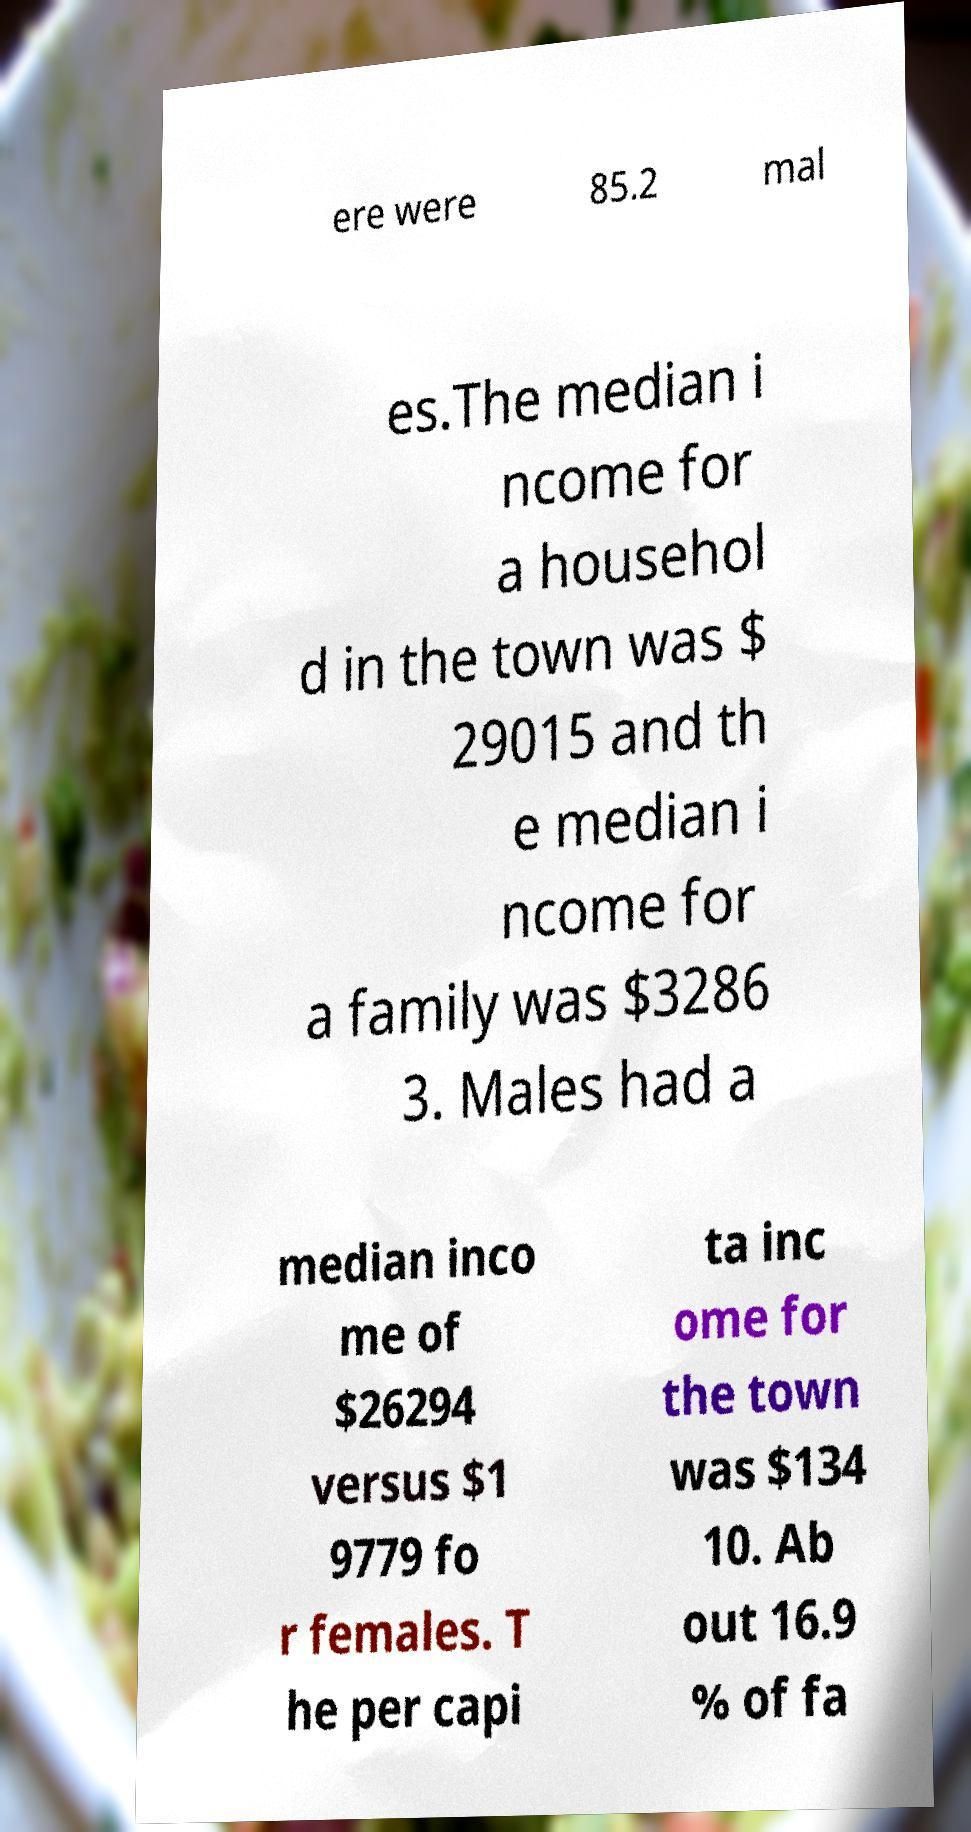I need the written content from this picture converted into text. Can you do that? ere were 85.2 mal es.The median i ncome for a househol d in the town was $ 29015 and th e median i ncome for a family was $3286 3. Males had a median inco me of $26294 versus $1 9779 fo r females. T he per capi ta inc ome for the town was $134 10. Ab out 16.9 % of fa 